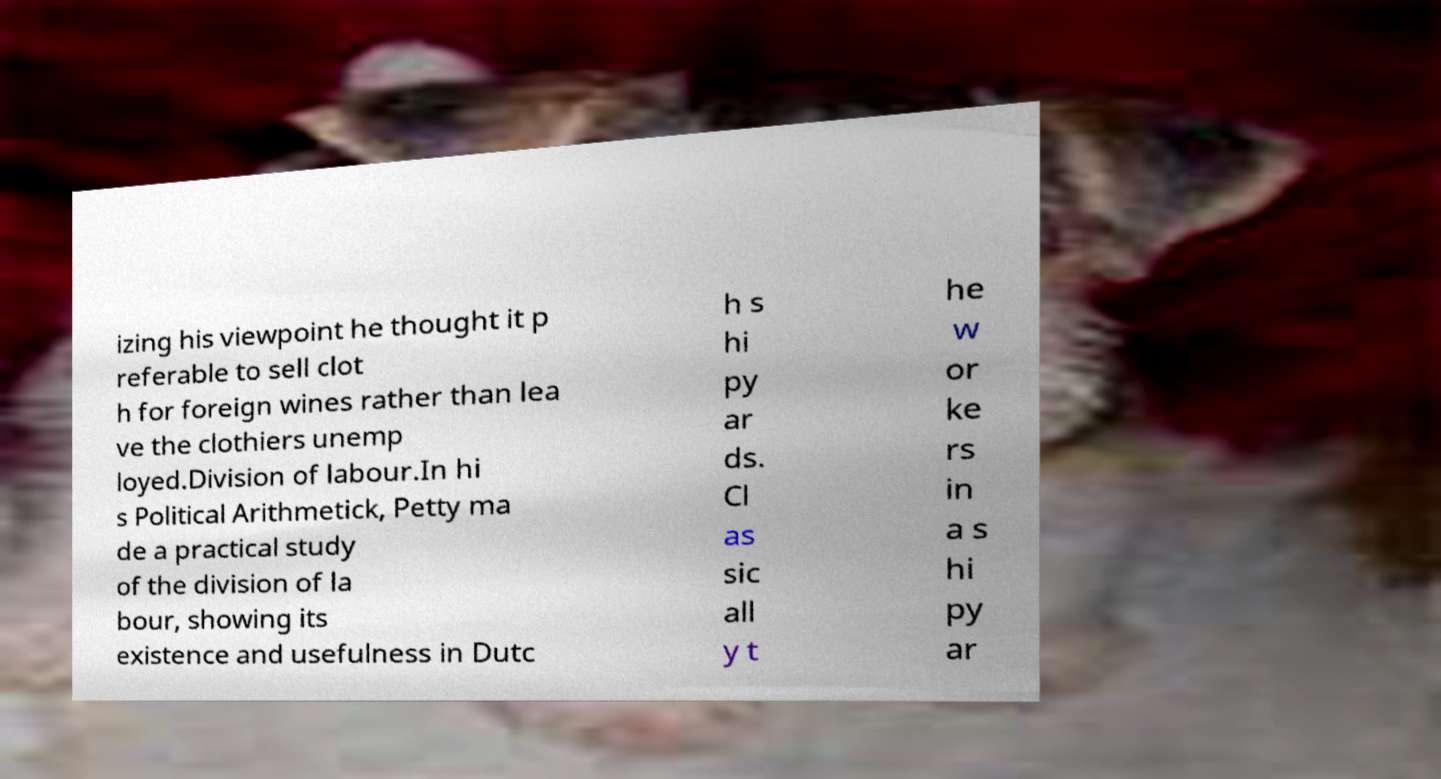Can you read and provide the text displayed in the image?This photo seems to have some interesting text. Can you extract and type it out for me? izing his viewpoint he thought it p referable to sell clot h for foreign wines rather than lea ve the clothiers unemp loyed.Division of labour.In hi s Political Arithmetick, Petty ma de a practical study of the division of la bour, showing its existence and usefulness in Dutc h s hi py ar ds. Cl as sic all y t he w or ke rs in a s hi py ar 